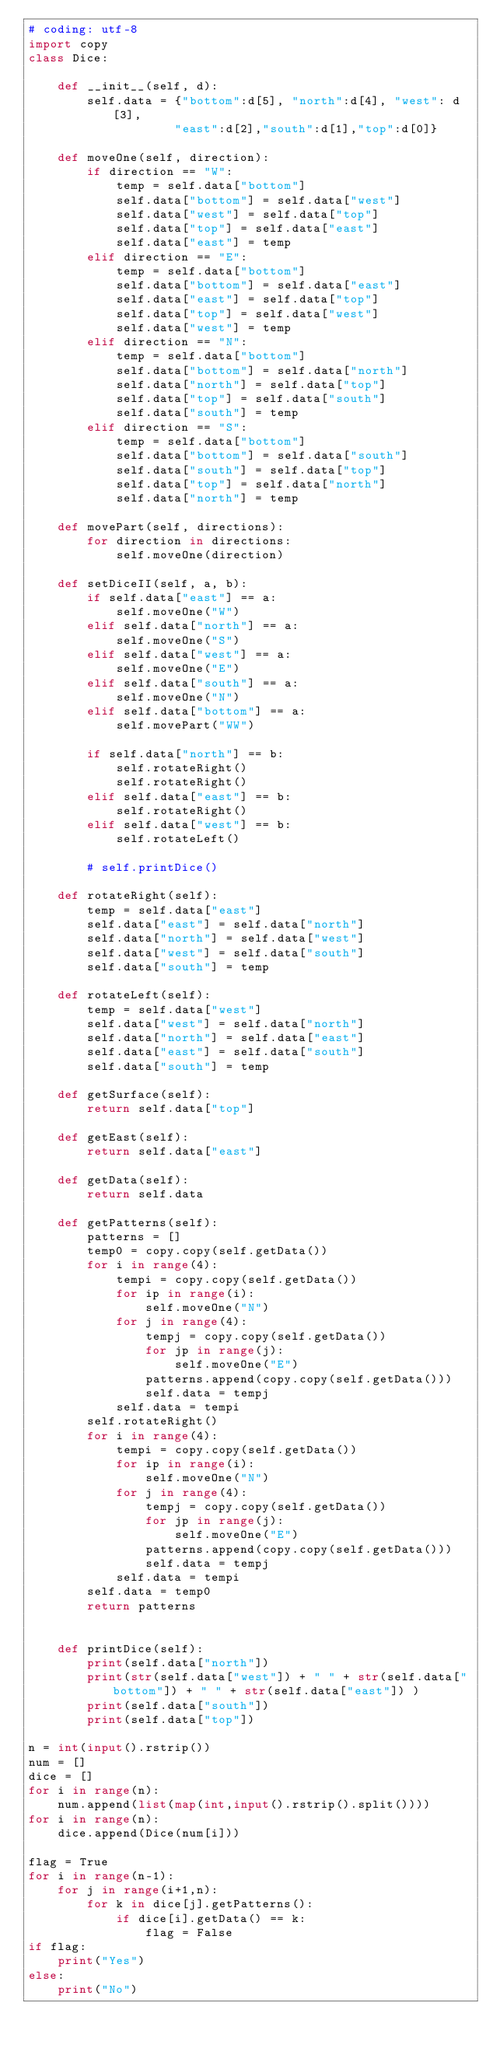Convert code to text. <code><loc_0><loc_0><loc_500><loc_500><_Python_># coding: utf-8
import copy
class Dice:
    
    def __init__(self, d):
        self.data = {"bottom":d[5], "north":d[4], "west": d[3],
                    "east":d[2],"south":d[1],"top":d[0]}

    def moveOne(self, direction):
        if direction == "W":
            temp = self.data["bottom"]
            self.data["bottom"] = self.data["west"]
            self.data["west"] = self.data["top"]
            self.data["top"] = self.data["east"]
            self.data["east"] = temp
        elif direction == "E":
            temp = self.data["bottom"]
            self.data["bottom"] = self.data["east"]
            self.data["east"] = self.data["top"]
            self.data["top"] = self.data["west"]
            self.data["west"] = temp
        elif direction == "N":
            temp = self.data["bottom"]
            self.data["bottom"] = self.data["north"]
            self.data["north"] = self.data["top"]
            self.data["top"] = self.data["south"]
            self.data["south"] = temp
        elif direction == "S":
            temp = self.data["bottom"]
            self.data["bottom"] = self.data["south"]
            self.data["south"] = self.data["top"]
            self.data["top"] = self.data["north"]
            self.data["north"] = temp

    def movePart(self, directions):
        for direction in directions:
            self.moveOne(direction)
            
    def setDiceII(self, a, b):
        if self.data["east"] == a:
            self.moveOne("W")
        elif self.data["north"] == a:
            self.moveOne("S")
        elif self.data["west"] == a:
            self.moveOne("E")
        elif self.data["south"] == a:
            self.moveOne("N")
        elif self.data["bottom"] == a:
            self.movePart("WW")

        if self.data["north"] == b:
            self.rotateRight()
            self.rotateRight()
        elif self.data["east"] == b:
            self.rotateRight()
        elif self.data["west"] == b:
            self.rotateLeft()
            
        # self.printDice()
    
    def rotateRight(self):
        temp = self.data["east"]
        self.data["east"] = self.data["north"]
        self.data["north"] = self.data["west"]
        self.data["west"] = self.data["south"]
        self.data["south"] = temp
    
    def rotateLeft(self):
        temp = self.data["west"]
        self.data["west"] = self.data["north"]
        self.data["north"] = self.data["east"]
        self.data["east"] = self.data["south"]
        self.data["south"] = temp
      
    def getSurface(self):
        return self.data["top"]
    
    def getEast(self):
        return self.data["east"]
    
    def getData(self):
        return self.data
    
    def getPatterns(self):
        patterns = []
        temp0 = copy.copy(self.getData())
        for i in range(4):
            tempi = copy.copy(self.getData())
            for ip in range(i):
                self.moveOne("N")
            for j in range(4):
                tempj = copy.copy(self.getData())
                for jp in range(j):
                    self.moveOne("E")
                patterns.append(copy.copy(self.getData()))
                self.data = tempj
            self.data = tempi
        self.rotateRight()
        for i in range(4):
            tempi = copy.copy(self.getData())
            for ip in range(i):
                self.moveOne("N")
            for j in range(4):
                tempj = copy.copy(self.getData())
                for jp in range(j):
                    self.moveOne("E")
                patterns.append(copy.copy(self.getData()))
                self.data = tempj
            self.data = tempi
        self.data = temp0
        return patterns
                

    def printDice(self):
        print(self.data["north"])
        print(str(self.data["west"]) + " " + str(self.data["bottom"]) + " " + str(self.data["east"]) )
        print(self.data["south"])
        print(self.data["top"])

n = int(input().rstrip())
num = []
dice = []
for i in range(n):
    num.append(list(map(int,input().rstrip().split())))
for i in range(n):
    dice.append(Dice(num[i]))

flag = True
for i in range(n-1):
    for j in range(i+1,n):
        for k in dice[j].getPatterns():
            if dice[i].getData() == k:
                flag = False
if flag:
    print("Yes")
else:
    print("No")
</code> 